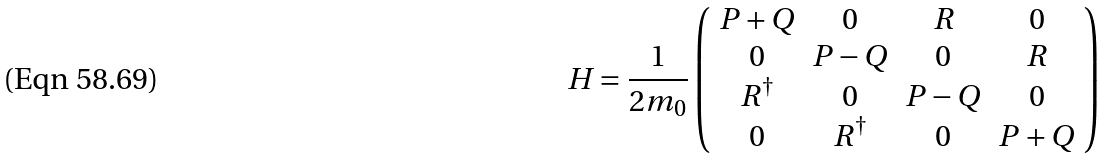<formula> <loc_0><loc_0><loc_500><loc_500>H = \frac { 1 } { 2 m _ { 0 } } \left ( \begin{array} { c c c c } P + Q & 0 & R & 0 \\ 0 & P - Q & 0 & R \\ R ^ { \dagger } & 0 & P - Q & 0 \\ 0 & R ^ { \dagger } & 0 & P + Q \end{array} \right )</formula> 